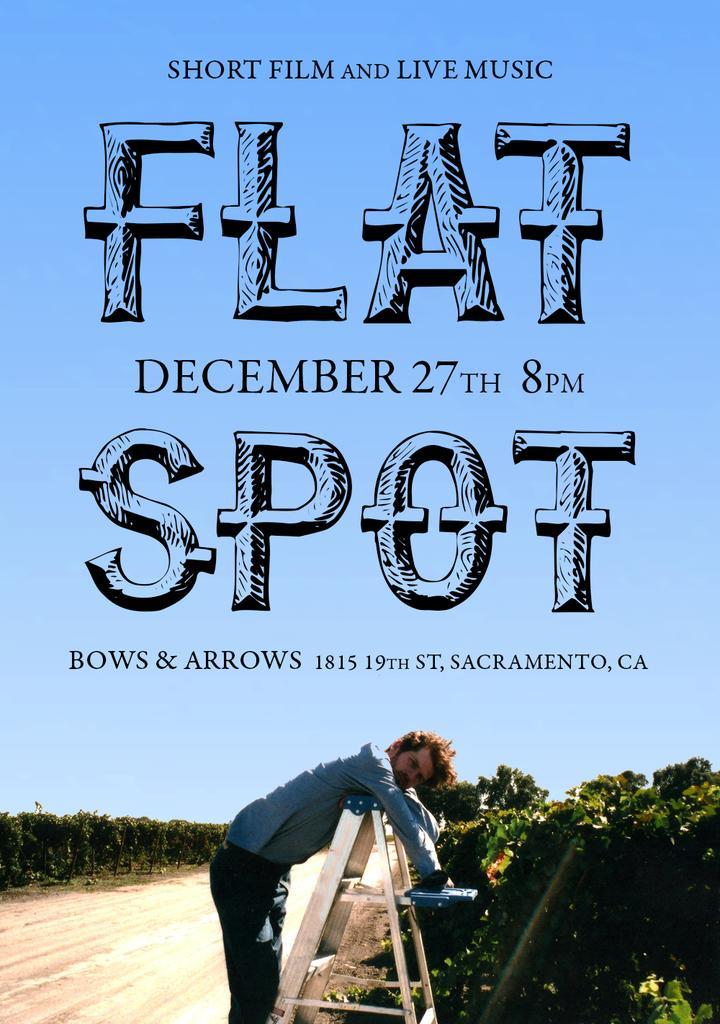How would you summarize this image in a sentence or two? In this picture, we can see a person lying on ladder, we can see the ground, trees, plants and the sky, and we can see some text. 